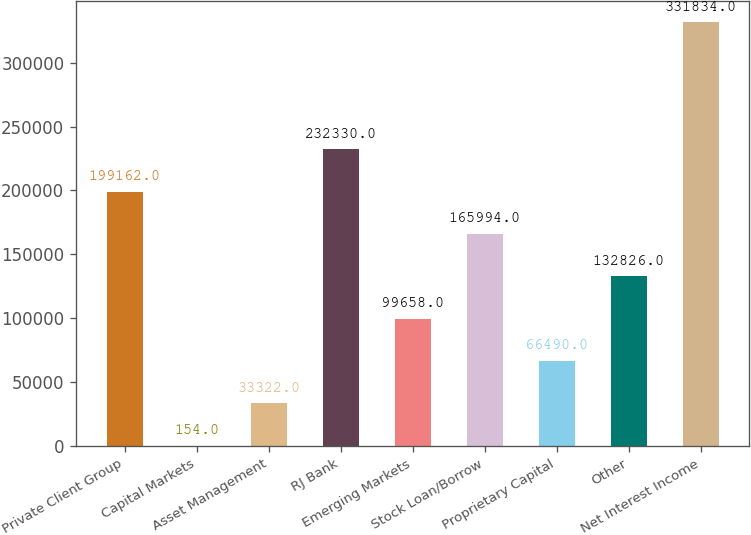Convert chart to OTSL. <chart><loc_0><loc_0><loc_500><loc_500><bar_chart><fcel>Private Client Group<fcel>Capital Markets<fcel>Asset Management<fcel>RJ Bank<fcel>Emerging Markets<fcel>Stock Loan/Borrow<fcel>Proprietary Capital<fcel>Other<fcel>Net Interest Income<nl><fcel>199162<fcel>154<fcel>33322<fcel>232330<fcel>99658<fcel>165994<fcel>66490<fcel>132826<fcel>331834<nl></chart> 